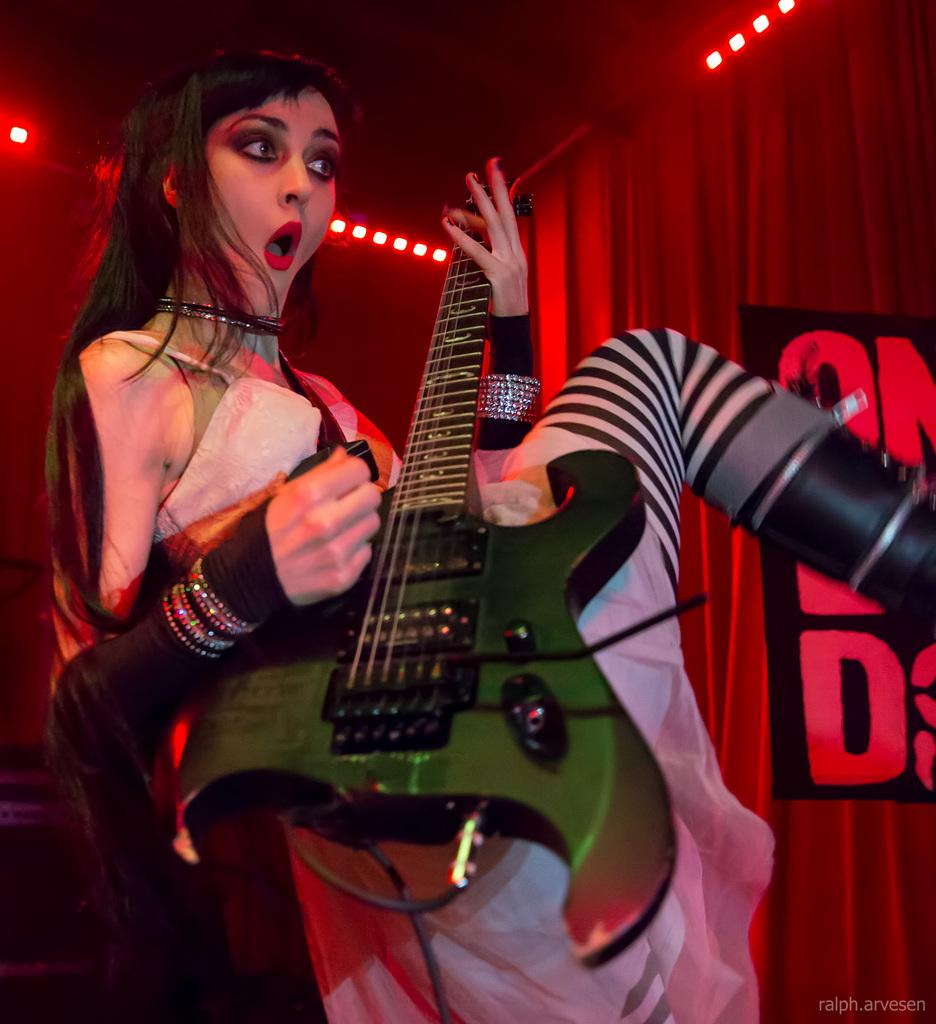Who is the main subject in the image? There is a lady in the center of the image. What is the lady doing in the image? The lady is standing and playing a guitar. What can be seen in the background of the image? There are lights and a curtain in the background of the image. How many planes are flying in the image? There are no planes visible in the image. What type of box is being used by the lady to play the guitar? The lady is not using a box to play the guitar; she is playing a traditional guitar. 